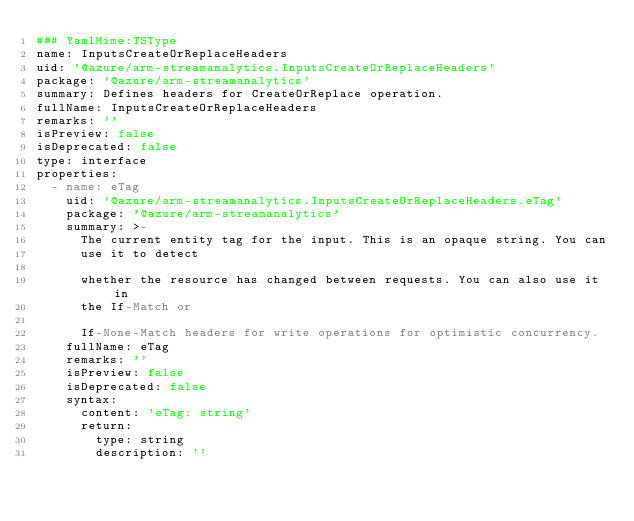Convert code to text. <code><loc_0><loc_0><loc_500><loc_500><_YAML_>### YamlMime:TSType
name: InputsCreateOrReplaceHeaders
uid: '@azure/arm-streamanalytics.InputsCreateOrReplaceHeaders'
package: '@azure/arm-streamanalytics'
summary: Defines headers for CreateOrReplace operation.
fullName: InputsCreateOrReplaceHeaders
remarks: ''
isPreview: false
isDeprecated: false
type: interface
properties:
  - name: eTag
    uid: '@azure/arm-streamanalytics.InputsCreateOrReplaceHeaders.eTag'
    package: '@azure/arm-streamanalytics'
    summary: >-
      The current entity tag for the input. This is an opaque string. You can
      use it to detect

      whether the resource has changed between requests. You can also use it in
      the If-Match or

      If-None-Match headers for write operations for optimistic concurrency.
    fullName: eTag
    remarks: ''
    isPreview: false
    isDeprecated: false
    syntax:
      content: 'eTag: string'
      return:
        type: string
        description: ''
</code> 